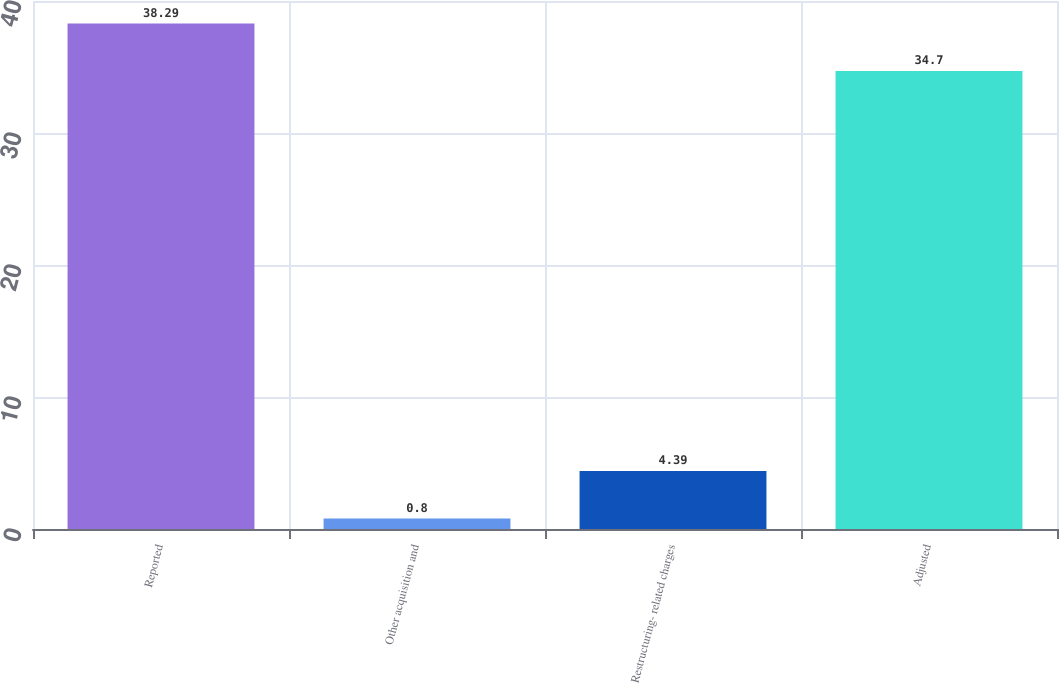Convert chart. <chart><loc_0><loc_0><loc_500><loc_500><bar_chart><fcel>Reported<fcel>Other acquisition and<fcel>Restructuring- related charges<fcel>Adjusted<nl><fcel>38.29<fcel>0.8<fcel>4.39<fcel>34.7<nl></chart> 